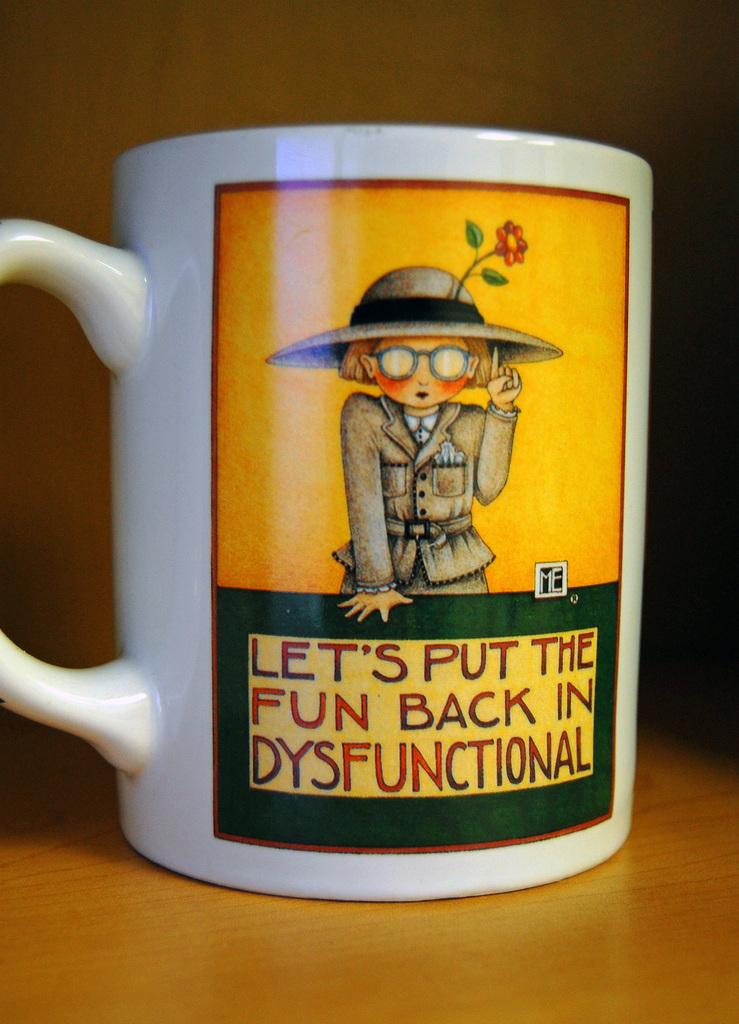<image>
Give a short and clear explanation of the subsequent image. A mug saying to put fun back in dysfunctional 